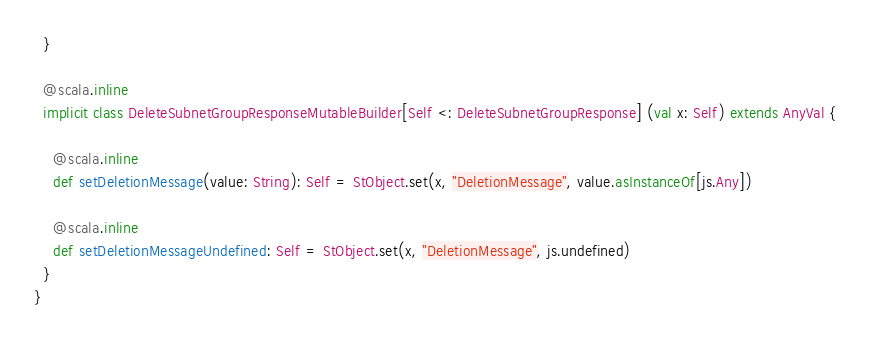Convert code to text. <code><loc_0><loc_0><loc_500><loc_500><_Scala_>  }
  
  @scala.inline
  implicit class DeleteSubnetGroupResponseMutableBuilder[Self <: DeleteSubnetGroupResponse] (val x: Self) extends AnyVal {
    
    @scala.inline
    def setDeletionMessage(value: String): Self = StObject.set(x, "DeletionMessage", value.asInstanceOf[js.Any])
    
    @scala.inline
    def setDeletionMessageUndefined: Self = StObject.set(x, "DeletionMessage", js.undefined)
  }
}
</code> 